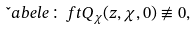<formula> <loc_0><loc_0><loc_500><loc_500>\L a b e l { e \colon f t } Q _ { \chi } ( z , \chi , 0 ) \not \equiv 0 ,</formula> 